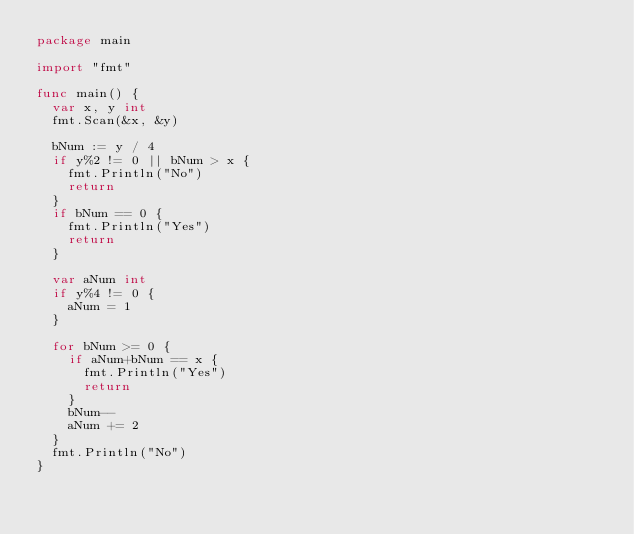<code> <loc_0><loc_0><loc_500><loc_500><_Go_>package main

import "fmt"

func main() {
	var x, y int
	fmt.Scan(&x, &y)

	bNum := y / 4
	if y%2 != 0 || bNum > x {
		fmt.Println("No")
		return
	}
	if bNum == 0 {
		fmt.Println("Yes")
		return
	}

	var aNum int
	if y%4 != 0 {
		aNum = 1
	}

	for bNum >= 0 {
		if aNum+bNum == x {
			fmt.Println("Yes")
			return
		}
		bNum--
		aNum += 2
	}
	fmt.Println("No")
}

</code> 